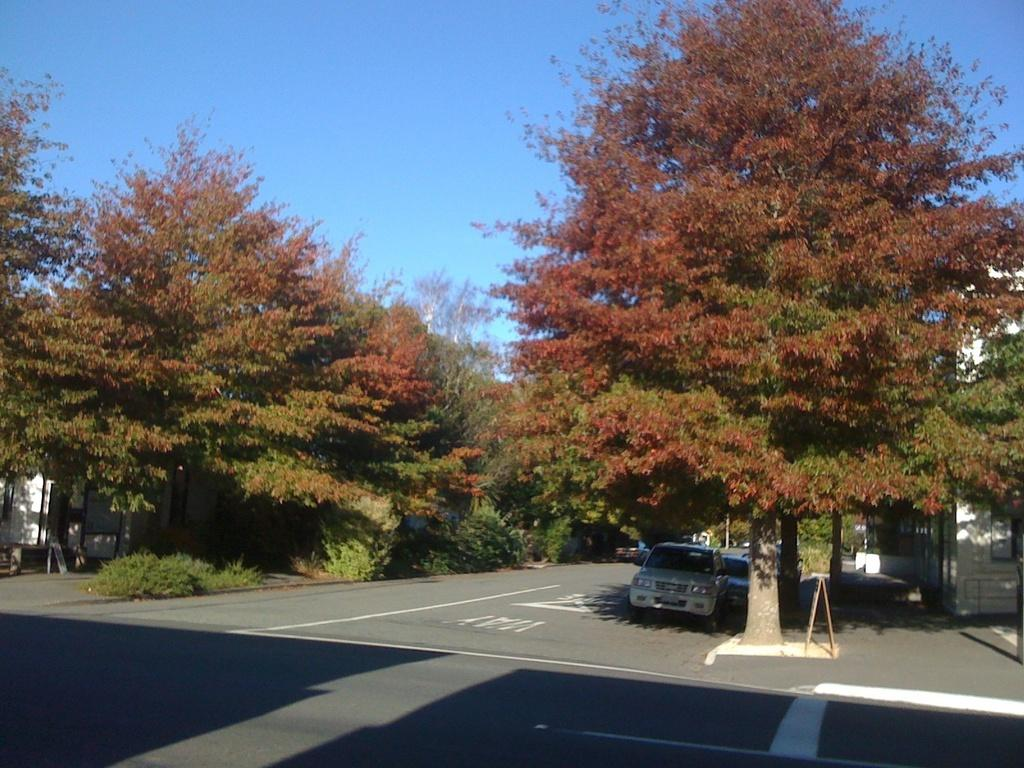What is located at the bottom of the image? There is a road at the bottom of the image. What can be seen traveling on the road? Cars are visible on the road. What is present in the center of the image? There are trees and buildings in the center of the image. What is visible in the background of the image? The sky is visible in the background of the image. Where is the crown located in the image? There is no crown present in the image. What type of division can be seen between the trees and buildings in the image? There is no division mentioned or visible between the trees and buildings in the image. 